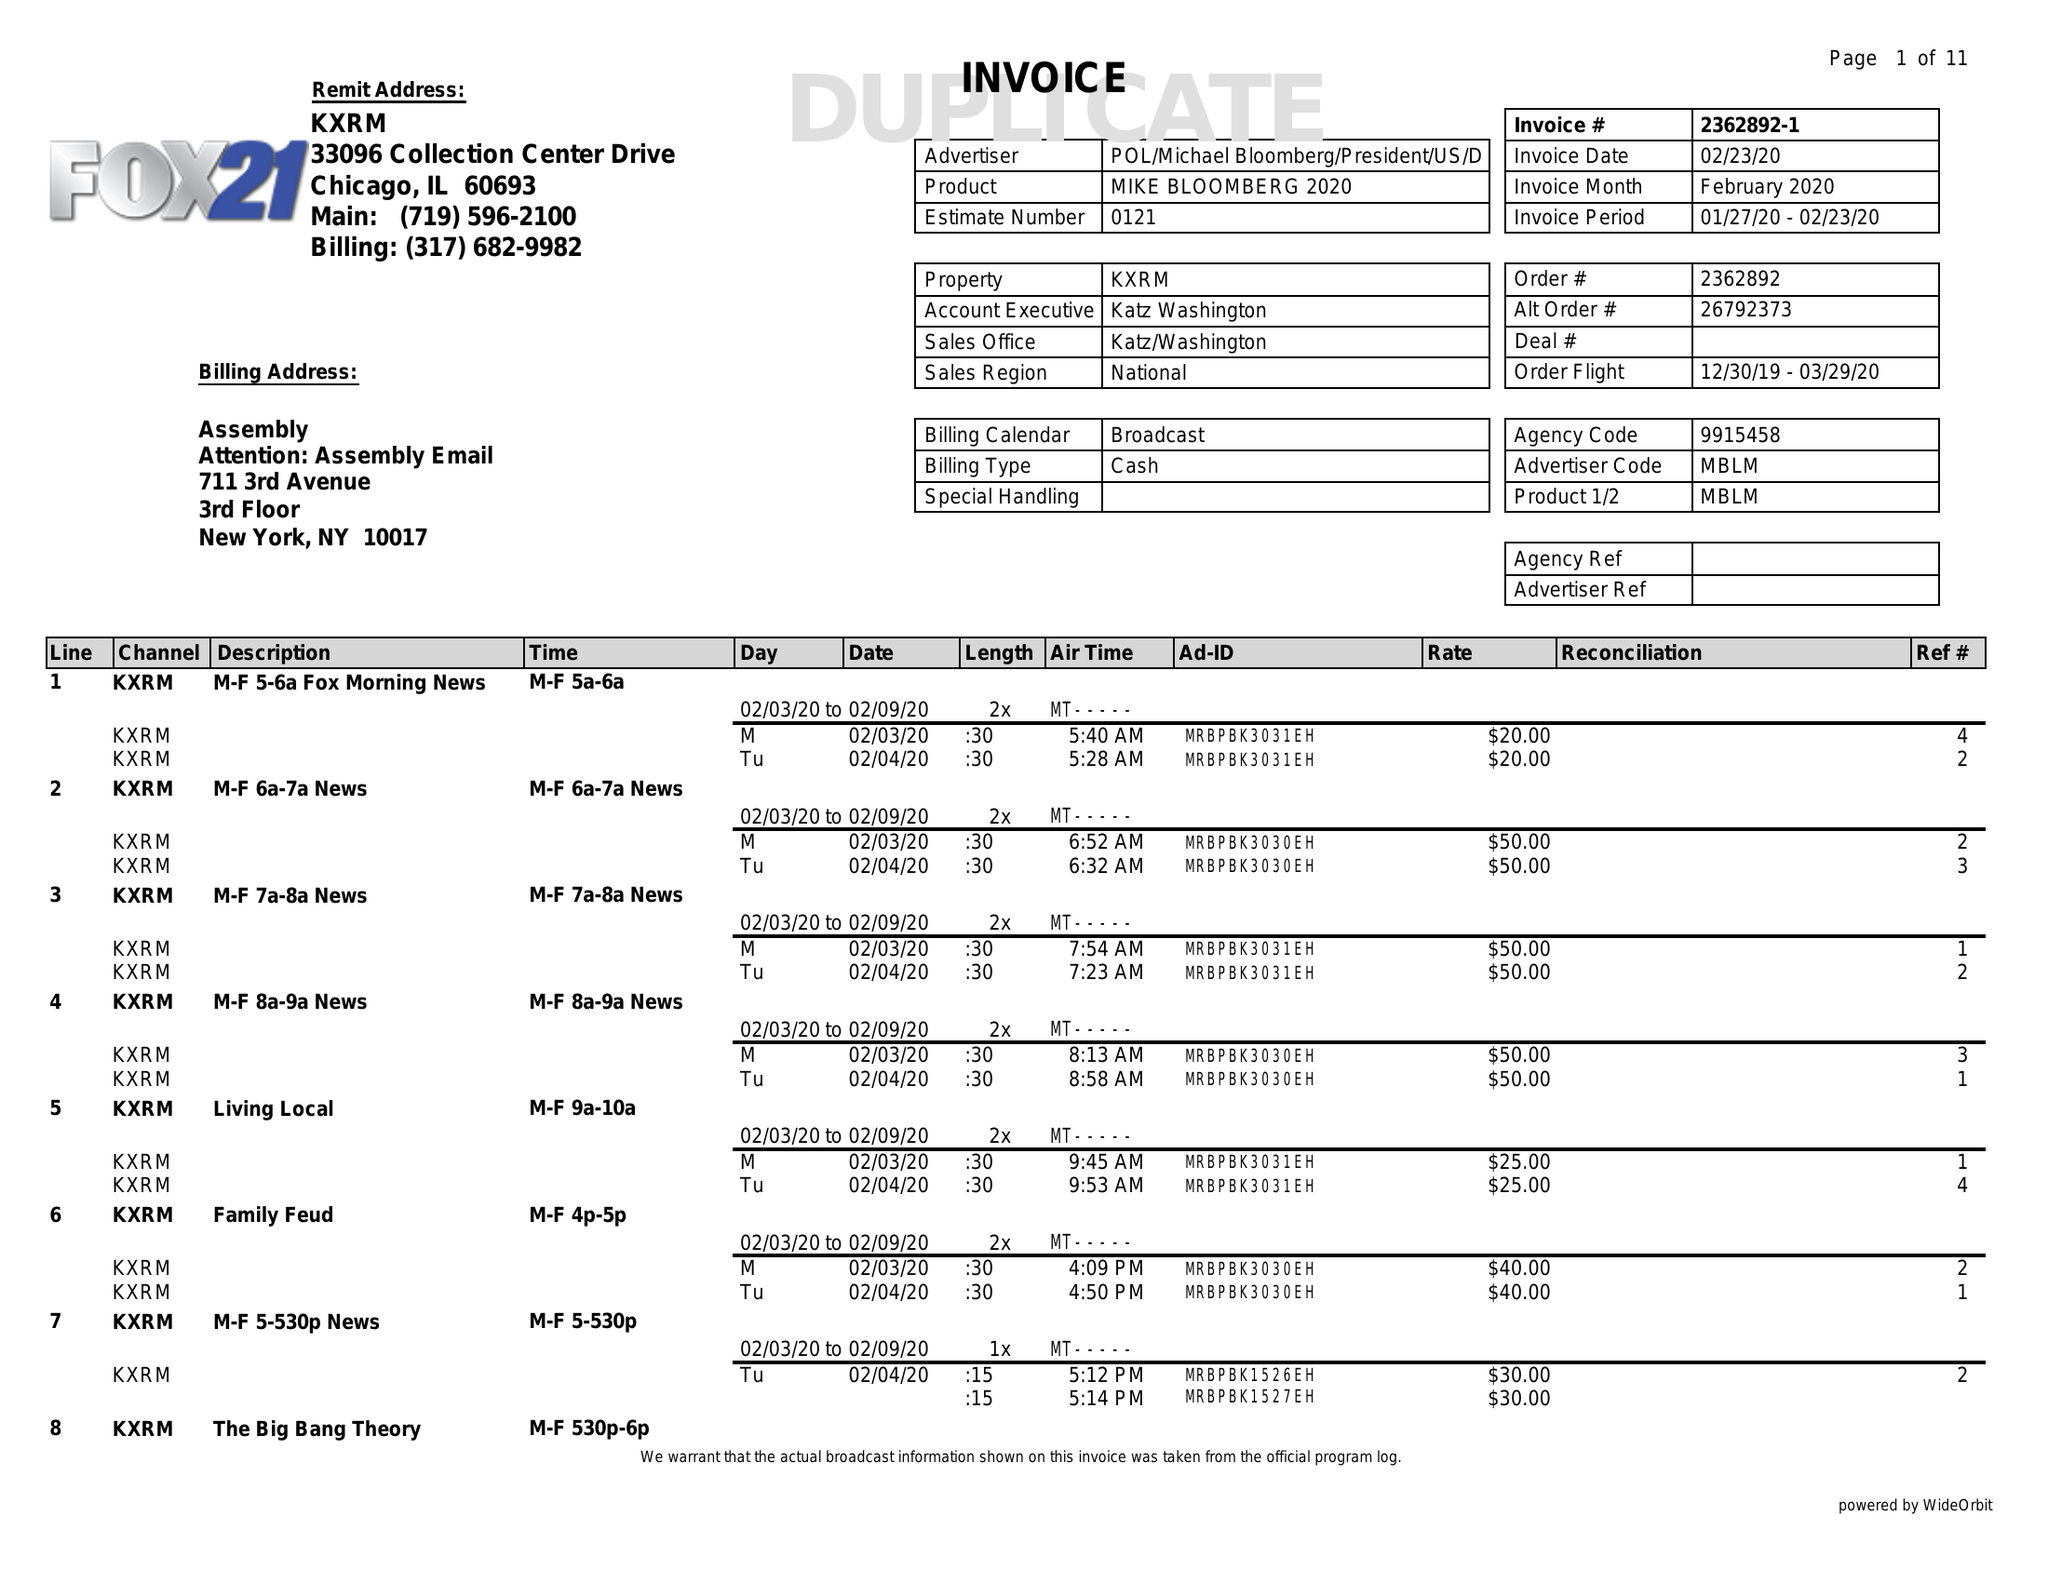What is the value for the contract_num?
Answer the question using a single word or phrase. 2362892 